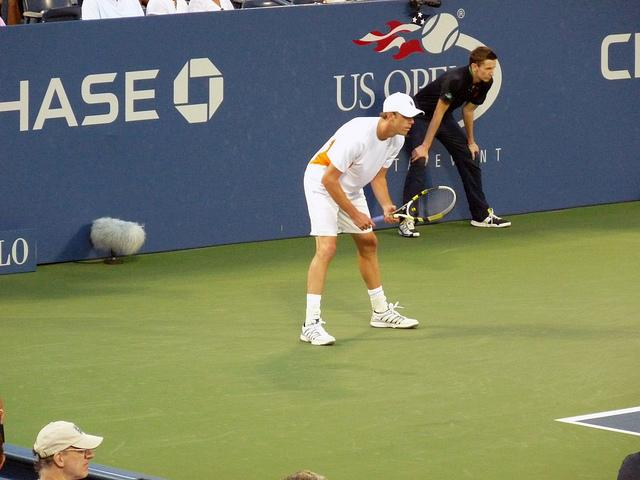What is the purpose of the white furry object? microphone 